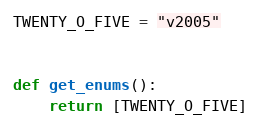<code> <loc_0><loc_0><loc_500><loc_500><_Python_>TWENTY_O_FIVE = "v2005"


def get_enums():
    return [TWENTY_O_FIVE]
</code> 